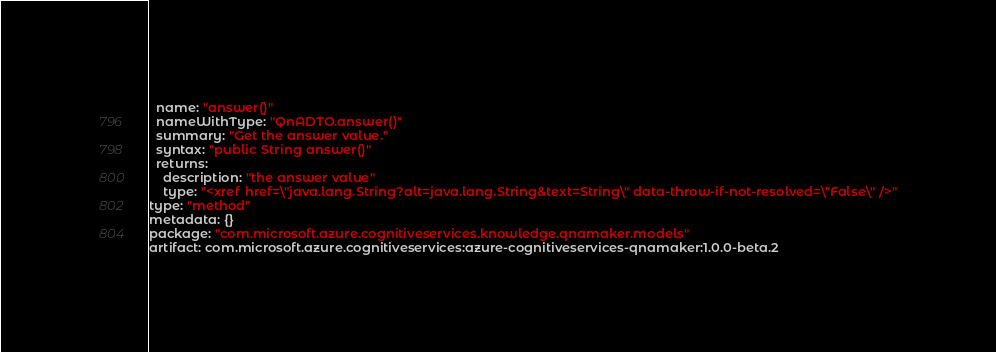<code> <loc_0><loc_0><loc_500><loc_500><_YAML_>  name: "answer()"
  nameWithType: "QnADTO.answer()"
  summary: "Get the answer value."
  syntax: "public String answer()"
  returns:
    description: "the answer value"
    type: "<xref href=\"java.lang.String?alt=java.lang.String&text=String\" data-throw-if-not-resolved=\"False\" />"
type: "method"
metadata: {}
package: "com.microsoft.azure.cognitiveservices.knowledge.qnamaker.models"
artifact: com.microsoft.azure.cognitiveservices:azure-cognitiveservices-qnamaker:1.0.0-beta.2
</code> 